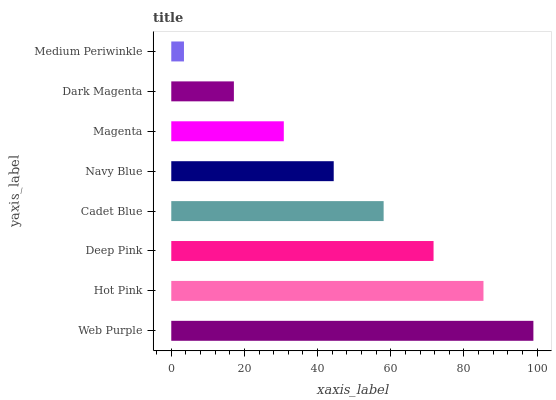Is Medium Periwinkle the minimum?
Answer yes or no. Yes. Is Web Purple the maximum?
Answer yes or no. Yes. Is Hot Pink the minimum?
Answer yes or no. No. Is Hot Pink the maximum?
Answer yes or no. No. Is Web Purple greater than Hot Pink?
Answer yes or no. Yes. Is Hot Pink less than Web Purple?
Answer yes or no. Yes. Is Hot Pink greater than Web Purple?
Answer yes or no. No. Is Web Purple less than Hot Pink?
Answer yes or no. No. Is Cadet Blue the high median?
Answer yes or no. Yes. Is Navy Blue the low median?
Answer yes or no. Yes. Is Deep Pink the high median?
Answer yes or no. No. Is Dark Magenta the low median?
Answer yes or no. No. 